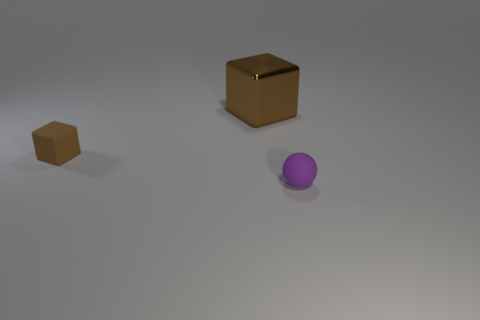What number of objects are brown things on the right side of the tiny brown rubber thing or tiny yellow cylinders?
Your response must be concise. 1. Is the color of the tiny matte thing that is left of the purple object the same as the big metallic block?
Your response must be concise. Yes. What number of other things are there of the same color as the tiny rubber block?
Your answer should be compact. 1. How many large things are either green rubber cubes or purple balls?
Provide a short and direct response. 0. Is the number of big red cubes greater than the number of tiny matte things?
Your response must be concise. No. Do the sphere and the large brown cube have the same material?
Offer a terse response. No. Are there any other things that have the same material as the tiny sphere?
Offer a very short reply. Yes. Are there more tiny blocks in front of the matte sphere than tiny purple rubber things?
Keep it short and to the point. No. Is the color of the large thing the same as the small sphere?
Make the answer very short. No. How many other big metal objects are the same shape as the brown metal thing?
Offer a very short reply. 0. 